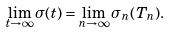Convert formula to latex. <formula><loc_0><loc_0><loc_500><loc_500>\lim _ { t \rightarrow \infty } \sigma ( t ) = \lim _ { n \rightarrow \infty } \sigma _ { n } ( T _ { n } ) .</formula> 